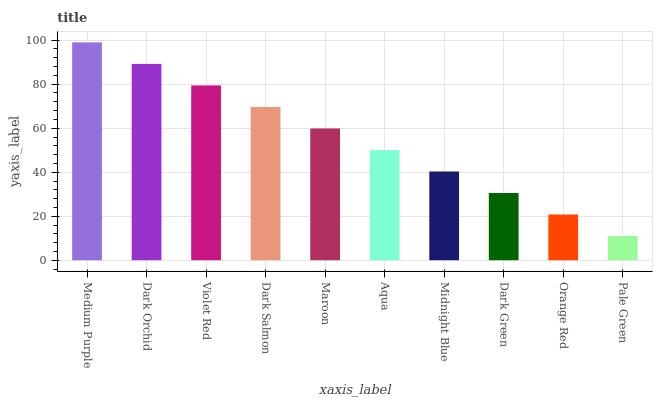Is Pale Green the minimum?
Answer yes or no. Yes. Is Medium Purple the maximum?
Answer yes or no. Yes. Is Dark Orchid the minimum?
Answer yes or no. No. Is Dark Orchid the maximum?
Answer yes or no. No. Is Medium Purple greater than Dark Orchid?
Answer yes or no. Yes. Is Dark Orchid less than Medium Purple?
Answer yes or no. Yes. Is Dark Orchid greater than Medium Purple?
Answer yes or no. No. Is Medium Purple less than Dark Orchid?
Answer yes or no. No. Is Maroon the high median?
Answer yes or no. Yes. Is Aqua the low median?
Answer yes or no. Yes. Is Pale Green the high median?
Answer yes or no. No. Is Medium Purple the low median?
Answer yes or no. No. 